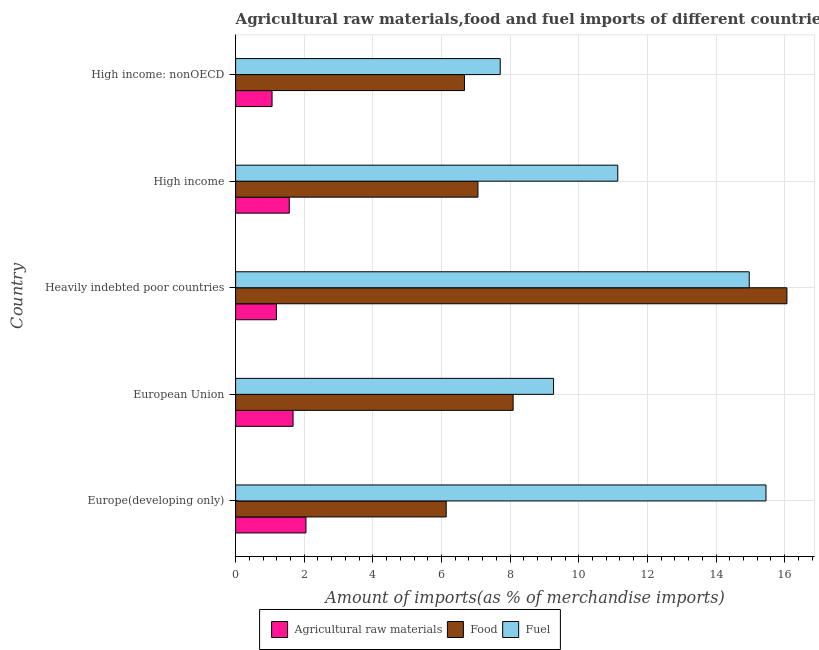How many groups of bars are there?
Offer a terse response. 5. Are the number of bars per tick equal to the number of legend labels?
Provide a succinct answer. Yes. How many bars are there on the 1st tick from the top?
Provide a succinct answer. 3. How many bars are there on the 1st tick from the bottom?
Your answer should be compact. 3. What is the label of the 1st group of bars from the top?
Give a very brief answer. High income: nonOECD. In how many cases, is the number of bars for a given country not equal to the number of legend labels?
Your answer should be compact. 0. What is the percentage of food imports in Europe(developing only)?
Provide a succinct answer. 6.14. Across all countries, what is the maximum percentage of raw materials imports?
Provide a short and direct response. 2.05. Across all countries, what is the minimum percentage of fuel imports?
Offer a very short reply. 7.71. In which country was the percentage of raw materials imports maximum?
Keep it short and to the point. Europe(developing only). In which country was the percentage of fuel imports minimum?
Ensure brevity in your answer.  High income: nonOECD. What is the total percentage of food imports in the graph?
Your answer should be compact. 44.02. What is the difference between the percentage of fuel imports in European Union and that in Heavily indebted poor countries?
Offer a terse response. -5.7. What is the difference between the percentage of food imports in Europe(developing only) and the percentage of fuel imports in Heavily indebted poor countries?
Give a very brief answer. -8.83. What is the average percentage of raw materials imports per country?
Ensure brevity in your answer.  1.51. What is the difference between the percentage of fuel imports and percentage of food imports in Europe(developing only)?
Give a very brief answer. 9.32. In how many countries, is the percentage of food imports greater than 6.8 %?
Your answer should be compact. 3. What is the ratio of the percentage of raw materials imports in Europe(developing only) to that in High income: nonOECD?
Make the answer very short. 1.93. Is the percentage of fuel imports in European Union less than that in High income: nonOECD?
Your answer should be compact. No. Is the difference between the percentage of fuel imports in High income and High income: nonOECD greater than the difference between the percentage of food imports in High income and High income: nonOECD?
Your response must be concise. Yes. What is the difference between the highest and the second highest percentage of fuel imports?
Your answer should be very brief. 0.49. What is the difference between the highest and the lowest percentage of fuel imports?
Offer a terse response. 7.74. In how many countries, is the percentage of fuel imports greater than the average percentage of fuel imports taken over all countries?
Ensure brevity in your answer.  2. Is the sum of the percentage of food imports in European Union and High income greater than the maximum percentage of fuel imports across all countries?
Keep it short and to the point. No. What does the 2nd bar from the top in Heavily indebted poor countries represents?
Provide a short and direct response. Food. What does the 1st bar from the bottom in High income represents?
Your answer should be compact. Agricultural raw materials. Is it the case that in every country, the sum of the percentage of raw materials imports and percentage of food imports is greater than the percentage of fuel imports?
Your response must be concise. No. What is the difference between two consecutive major ticks on the X-axis?
Offer a terse response. 2. Are the values on the major ticks of X-axis written in scientific E-notation?
Give a very brief answer. No. Does the graph contain grids?
Offer a terse response. Yes. How many legend labels are there?
Provide a succinct answer. 3. What is the title of the graph?
Offer a terse response. Agricultural raw materials,food and fuel imports of different countries in 2004. Does "Resident buildings and public services" appear as one of the legend labels in the graph?
Ensure brevity in your answer.  No. What is the label or title of the X-axis?
Make the answer very short. Amount of imports(as % of merchandise imports). What is the Amount of imports(as % of merchandise imports) of Agricultural raw materials in Europe(developing only)?
Keep it short and to the point. 2.05. What is the Amount of imports(as % of merchandise imports) in Food in Europe(developing only)?
Your answer should be compact. 6.14. What is the Amount of imports(as % of merchandise imports) of Fuel in Europe(developing only)?
Offer a terse response. 15.45. What is the Amount of imports(as % of merchandise imports) in Agricultural raw materials in European Union?
Keep it short and to the point. 1.67. What is the Amount of imports(as % of merchandise imports) in Food in European Union?
Make the answer very short. 8.09. What is the Amount of imports(as % of merchandise imports) in Fuel in European Union?
Make the answer very short. 9.26. What is the Amount of imports(as % of merchandise imports) of Agricultural raw materials in Heavily indebted poor countries?
Provide a short and direct response. 1.19. What is the Amount of imports(as % of merchandise imports) of Food in Heavily indebted poor countries?
Give a very brief answer. 16.06. What is the Amount of imports(as % of merchandise imports) in Fuel in Heavily indebted poor countries?
Ensure brevity in your answer.  14.97. What is the Amount of imports(as % of merchandise imports) of Agricultural raw materials in High income?
Provide a short and direct response. 1.56. What is the Amount of imports(as % of merchandise imports) in Food in High income?
Provide a succinct answer. 7.06. What is the Amount of imports(as % of merchandise imports) in Fuel in High income?
Your answer should be compact. 11.14. What is the Amount of imports(as % of merchandise imports) in Agricultural raw materials in High income: nonOECD?
Provide a short and direct response. 1.06. What is the Amount of imports(as % of merchandise imports) in Food in High income: nonOECD?
Keep it short and to the point. 6.67. What is the Amount of imports(as % of merchandise imports) in Fuel in High income: nonOECD?
Ensure brevity in your answer.  7.71. Across all countries, what is the maximum Amount of imports(as % of merchandise imports) of Agricultural raw materials?
Offer a very short reply. 2.05. Across all countries, what is the maximum Amount of imports(as % of merchandise imports) in Food?
Make the answer very short. 16.06. Across all countries, what is the maximum Amount of imports(as % of merchandise imports) in Fuel?
Offer a very short reply. 15.45. Across all countries, what is the minimum Amount of imports(as % of merchandise imports) of Agricultural raw materials?
Provide a succinct answer. 1.06. Across all countries, what is the minimum Amount of imports(as % of merchandise imports) in Food?
Provide a short and direct response. 6.14. Across all countries, what is the minimum Amount of imports(as % of merchandise imports) of Fuel?
Keep it short and to the point. 7.71. What is the total Amount of imports(as % of merchandise imports) in Agricultural raw materials in the graph?
Give a very brief answer. 7.54. What is the total Amount of imports(as % of merchandise imports) in Food in the graph?
Offer a very short reply. 44.02. What is the total Amount of imports(as % of merchandise imports) in Fuel in the graph?
Provide a short and direct response. 58.53. What is the difference between the Amount of imports(as % of merchandise imports) in Agricultural raw materials in Europe(developing only) and that in European Union?
Provide a short and direct response. 0.38. What is the difference between the Amount of imports(as % of merchandise imports) of Food in Europe(developing only) and that in European Union?
Make the answer very short. -1.95. What is the difference between the Amount of imports(as % of merchandise imports) in Fuel in Europe(developing only) and that in European Union?
Ensure brevity in your answer.  6.19. What is the difference between the Amount of imports(as % of merchandise imports) in Agricultural raw materials in Europe(developing only) and that in Heavily indebted poor countries?
Your answer should be very brief. 0.86. What is the difference between the Amount of imports(as % of merchandise imports) in Food in Europe(developing only) and that in Heavily indebted poor countries?
Provide a succinct answer. -9.93. What is the difference between the Amount of imports(as % of merchandise imports) of Fuel in Europe(developing only) and that in Heavily indebted poor countries?
Offer a very short reply. 0.49. What is the difference between the Amount of imports(as % of merchandise imports) in Agricultural raw materials in Europe(developing only) and that in High income?
Provide a short and direct response. 0.49. What is the difference between the Amount of imports(as % of merchandise imports) of Food in Europe(developing only) and that in High income?
Give a very brief answer. -0.92. What is the difference between the Amount of imports(as % of merchandise imports) in Fuel in Europe(developing only) and that in High income?
Provide a short and direct response. 4.32. What is the difference between the Amount of imports(as % of merchandise imports) in Agricultural raw materials in Europe(developing only) and that in High income: nonOECD?
Offer a very short reply. 0.99. What is the difference between the Amount of imports(as % of merchandise imports) in Food in Europe(developing only) and that in High income: nonOECD?
Make the answer very short. -0.53. What is the difference between the Amount of imports(as % of merchandise imports) in Fuel in Europe(developing only) and that in High income: nonOECD?
Your answer should be very brief. 7.74. What is the difference between the Amount of imports(as % of merchandise imports) in Agricultural raw materials in European Union and that in Heavily indebted poor countries?
Offer a terse response. 0.49. What is the difference between the Amount of imports(as % of merchandise imports) of Food in European Union and that in Heavily indebted poor countries?
Ensure brevity in your answer.  -7.98. What is the difference between the Amount of imports(as % of merchandise imports) of Fuel in European Union and that in Heavily indebted poor countries?
Your response must be concise. -5.7. What is the difference between the Amount of imports(as % of merchandise imports) of Agricultural raw materials in European Union and that in High income?
Your answer should be very brief. 0.11. What is the difference between the Amount of imports(as % of merchandise imports) of Food in European Union and that in High income?
Your response must be concise. 1.03. What is the difference between the Amount of imports(as % of merchandise imports) of Fuel in European Union and that in High income?
Offer a very short reply. -1.87. What is the difference between the Amount of imports(as % of merchandise imports) in Agricultural raw materials in European Union and that in High income: nonOECD?
Ensure brevity in your answer.  0.61. What is the difference between the Amount of imports(as % of merchandise imports) of Food in European Union and that in High income: nonOECD?
Ensure brevity in your answer.  1.42. What is the difference between the Amount of imports(as % of merchandise imports) in Fuel in European Union and that in High income: nonOECD?
Give a very brief answer. 1.55. What is the difference between the Amount of imports(as % of merchandise imports) of Agricultural raw materials in Heavily indebted poor countries and that in High income?
Your answer should be very brief. -0.38. What is the difference between the Amount of imports(as % of merchandise imports) in Food in Heavily indebted poor countries and that in High income?
Offer a terse response. 9. What is the difference between the Amount of imports(as % of merchandise imports) in Fuel in Heavily indebted poor countries and that in High income?
Provide a succinct answer. 3.83. What is the difference between the Amount of imports(as % of merchandise imports) of Agricultural raw materials in Heavily indebted poor countries and that in High income: nonOECD?
Ensure brevity in your answer.  0.13. What is the difference between the Amount of imports(as % of merchandise imports) of Food in Heavily indebted poor countries and that in High income: nonOECD?
Make the answer very short. 9.4. What is the difference between the Amount of imports(as % of merchandise imports) in Fuel in Heavily indebted poor countries and that in High income: nonOECD?
Your answer should be very brief. 7.26. What is the difference between the Amount of imports(as % of merchandise imports) of Agricultural raw materials in High income and that in High income: nonOECD?
Offer a terse response. 0.5. What is the difference between the Amount of imports(as % of merchandise imports) of Food in High income and that in High income: nonOECD?
Provide a succinct answer. 0.39. What is the difference between the Amount of imports(as % of merchandise imports) in Fuel in High income and that in High income: nonOECD?
Your answer should be compact. 3.43. What is the difference between the Amount of imports(as % of merchandise imports) in Agricultural raw materials in Europe(developing only) and the Amount of imports(as % of merchandise imports) in Food in European Union?
Ensure brevity in your answer.  -6.04. What is the difference between the Amount of imports(as % of merchandise imports) in Agricultural raw materials in Europe(developing only) and the Amount of imports(as % of merchandise imports) in Fuel in European Union?
Make the answer very short. -7.22. What is the difference between the Amount of imports(as % of merchandise imports) of Food in Europe(developing only) and the Amount of imports(as % of merchandise imports) of Fuel in European Union?
Give a very brief answer. -3.13. What is the difference between the Amount of imports(as % of merchandise imports) of Agricultural raw materials in Europe(developing only) and the Amount of imports(as % of merchandise imports) of Food in Heavily indebted poor countries?
Provide a short and direct response. -14.02. What is the difference between the Amount of imports(as % of merchandise imports) in Agricultural raw materials in Europe(developing only) and the Amount of imports(as % of merchandise imports) in Fuel in Heavily indebted poor countries?
Your response must be concise. -12.92. What is the difference between the Amount of imports(as % of merchandise imports) in Food in Europe(developing only) and the Amount of imports(as % of merchandise imports) in Fuel in Heavily indebted poor countries?
Keep it short and to the point. -8.83. What is the difference between the Amount of imports(as % of merchandise imports) in Agricultural raw materials in Europe(developing only) and the Amount of imports(as % of merchandise imports) in Food in High income?
Keep it short and to the point. -5.01. What is the difference between the Amount of imports(as % of merchandise imports) of Agricultural raw materials in Europe(developing only) and the Amount of imports(as % of merchandise imports) of Fuel in High income?
Provide a succinct answer. -9.09. What is the difference between the Amount of imports(as % of merchandise imports) of Food in Europe(developing only) and the Amount of imports(as % of merchandise imports) of Fuel in High income?
Offer a very short reply. -5. What is the difference between the Amount of imports(as % of merchandise imports) in Agricultural raw materials in Europe(developing only) and the Amount of imports(as % of merchandise imports) in Food in High income: nonOECD?
Make the answer very short. -4.62. What is the difference between the Amount of imports(as % of merchandise imports) in Agricultural raw materials in Europe(developing only) and the Amount of imports(as % of merchandise imports) in Fuel in High income: nonOECD?
Keep it short and to the point. -5.66. What is the difference between the Amount of imports(as % of merchandise imports) of Food in Europe(developing only) and the Amount of imports(as % of merchandise imports) of Fuel in High income: nonOECD?
Your answer should be compact. -1.57. What is the difference between the Amount of imports(as % of merchandise imports) in Agricultural raw materials in European Union and the Amount of imports(as % of merchandise imports) in Food in Heavily indebted poor countries?
Ensure brevity in your answer.  -14.39. What is the difference between the Amount of imports(as % of merchandise imports) of Agricultural raw materials in European Union and the Amount of imports(as % of merchandise imports) of Fuel in Heavily indebted poor countries?
Give a very brief answer. -13.29. What is the difference between the Amount of imports(as % of merchandise imports) of Food in European Union and the Amount of imports(as % of merchandise imports) of Fuel in Heavily indebted poor countries?
Keep it short and to the point. -6.88. What is the difference between the Amount of imports(as % of merchandise imports) of Agricultural raw materials in European Union and the Amount of imports(as % of merchandise imports) of Food in High income?
Your answer should be very brief. -5.39. What is the difference between the Amount of imports(as % of merchandise imports) in Agricultural raw materials in European Union and the Amount of imports(as % of merchandise imports) in Fuel in High income?
Keep it short and to the point. -9.46. What is the difference between the Amount of imports(as % of merchandise imports) of Food in European Union and the Amount of imports(as % of merchandise imports) of Fuel in High income?
Offer a very short reply. -3.05. What is the difference between the Amount of imports(as % of merchandise imports) of Agricultural raw materials in European Union and the Amount of imports(as % of merchandise imports) of Food in High income: nonOECD?
Your response must be concise. -4.99. What is the difference between the Amount of imports(as % of merchandise imports) in Agricultural raw materials in European Union and the Amount of imports(as % of merchandise imports) in Fuel in High income: nonOECD?
Offer a very short reply. -6.04. What is the difference between the Amount of imports(as % of merchandise imports) in Food in European Union and the Amount of imports(as % of merchandise imports) in Fuel in High income: nonOECD?
Keep it short and to the point. 0.38. What is the difference between the Amount of imports(as % of merchandise imports) of Agricultural raw materials in Heavily indebted poor countries and the Amount of imports(as % of merchandise imports) of Food in High income?
Your answer should be very brief. -5.87. What is the difference between the Amount of imports(as % of merchandise imports) of Agricultural raw materials in Heavily indebted poor countries and the Amount of imports(as % of merchandise imports) of Fuel in High income?
Your response must be concise. -9.95. What is the difference between the Amount of imports(as % of merchandise imports) in Food in Heavily indebted poor countries and the Amount of imports(as % of merchandise imports) in Fuel in High income?
Ensure brevity in your answer.  4.93. What is the difference between the Amount of imports(as % of merchandise imports) in Agricultural raw materials in Heavily indebted poor countries and the Amount of imports(as % of merchandise imports) in Food in High income: nonOECD?
Your answer should be compact. -5.48. What is the difference between the Amount of imports(as % of merchandise imports) of Agricultural raw materials in Heavily indebted poor countries and the Amount of imports(as % of merchandise imports) of Fuel in High income: nonOECD?
Your answer should be very brief. -6.52. What is the difference between the Amount of imports(as % of merchandise imports) of Food in Heavily indebted poor countries and the Amount of imports(as % of merchandise imports) of Fuel in High income: nonOECD?
Provide a succinct answer. 8.35. What is the difference between the Amount of imports(as % of merchandise imports) in Agricultural raw materials in High income and the Amount of imports(as % of merchandise imports) in Food in High income: nonOECD?
Your answer should be compact. -5.1. What is the difference between the Amount of imports(as % of merchandise imports) in Agricultural raw materials in High income and the Amount of imports(as % of merchandise imports) in Fuel in High income: nonOECD?
Keep it short and to the point. -6.15. What is the difference between the Amount of imports(as % of merchandise imports) in Food in High income and the Amount of imports(as % of merchandise imports) in Fuel in High income: nonOECD?
Give a very brief answer. -0.65. What is the average Amount of imports(as % of merchandise imports) of Agricultural raw materials per country?
Make the answer very short. 1.51. What is the average Amount of imports(as % of merchandise imports) of Food per country?
Make the answer very short. 8.8. What is the average Amount of imports(as % of merchandise imports) of Fuel per country?
Your answer should be compact. 11.71. What is the difference between the Amount of imports(as % of merchandise imports) in Agricultural raw materials and Amount of imports(as % of merchandise imports) in Food in Europe(developing only)?
Keep it short and to the point. -4.09. What is the difference between the Amount of imports(as % of merchandise imports) in Agricultural raw materials and Amount of imports(as % of merchandise imports) in Fuel in Europe(developing only)?
Keep it short and to the point. -13.41. What is the difference between the Amount of imports(as % of merchandise imports) of Food and Amount of imports(as % of merchandise imports) of Fuel in Europe(developing only)?
Your answer should be compact. -9.32. What is the difference between the Amount of imports(as % of merchandise imports) in Agricultural raw materials and Amount of imports(as % of merchandise imports) in Food in European Union?
Make the answer very short. -6.41. What is the difference between the Amount of imports(as % of merchandise imports) of Agricultural raw materials and Amount of imports(as % of merchandise imports) of Fuel in European Union?
Your answer should be compact. -7.59. What is the difference between the Amount of imports(as % of merchandise imports) in Food and Amount of imports(as % of merchandise imports) in Fuel in European Union?
Your answer should be very brief. -1.18. What is the difference between the Amount of imports(as % of merchandise imports) of Agricultural raw materials and Amount of imports(as % of merchandise imports) of Food in Heavily indebted poor countries?
Keep it short and to the point. -14.88. What is the difference between the Amount of imports(as % of merchandise imports) of Agricultural raw materials and Amount of imports(as % of merchandise imports) of Fuel in Heavily indebted poor countries?
Your response must be concise. -13.78. What is the difference between the Amount of imports(as % of merchandise imports) in Food and Amount of imports(as % of merchandise imports) in Fuel in Heavily indebted poor countries?
Your response must be concise. 1.1. What is the difference between the Amount of imports(as % of merchandise imports) of Agricultural raw materials and Amount of imports(as % of merchandise imports) of Food in High income?
Your answer should be compact. -5.5. What is the difference between the Amount of imports(as % of merchandise imports) in Agricultural raw materials and Amount of imports(as % of merchandise imports) in Fuel in High income?
Offer a terse response. -9.57. What is the difference between the Amount of imports(as % of merchandise imports) in Food and Amount of imports(as % of merchandise imports) in Fuel in High income?
Offer a terse response. -4.07. What is the difference between the Amount of imports(as % of merchandise imports) of Agricultural raw materials and Amount of imports(as % of merchandise imports) of Food in High income: nonOECD?
Keep it short and to the point. -5.61. What is the difference between the Amount of imports(as % of merchandise imports) of Agricultural raw materials and Amount of imports(as % of merchandise imports) of Fuel in High income: nonOECD?
Your answer should be compact. -6.65. What is the difference between the Amount of imports(as % of merchandise imports) in Food and Amount of imports(as % of merchandise imports) in Fuel in High income: nonOECD?
Give a very brief answer. -1.04. What is the ratio of the Amount of imports(as % of merchandise imports) of Agricultural raw materials in Europe(developing only) to that in European Union?
Provide a short and direct response. 1.22. What is the ratio of the Amount of imports(as % of merchandise imports) of Food in Europe(developing only) to that in European Union?
Give a very brief answer. 0.76. What is the ratio of the Amount of imports(as % of merchandise imports) in Fuel in Europe(developing only) to that in European Union?
Provide a short and direct response. 1.67. What is the ratio of the Amount of imports(as % of merchandise imports) of Agricultural raw materials in Europe(developing only) to that in Heavily indebted poor countries?
Offer a terse response. 1.73. What is the ratio of the Amount of imports(as % of merchandise imports) in Food in Europe(developing only) to that in Heavily indebted poor countries?
Your answer should be very brief. 0.38. What is the ratio of the Amount of imports(as % of merchandise imports) of Fuel in Europe(developing only) to that in Heavily indebted poor countries?
Your answer should be very brief. 1.03. What is the ratio of the Amount of imports(as % of merchandise imports) of Agricultural raw materials in Europe(developing only) to that in High income?
Your response must be concise. 1.31. What is the ratio of the Amount of imports(as % of merchandise imports) in Food in Europe(developing only) to that in High income?
Keep it short and to the point. 0.87. What is the ratio of the Amount of imports(as % of merchandise imports) of Fuel in Europe(developing only) to that in High income?
Make the answer very short. 1.39. What is the ratio of the Amount of imports(as % of merchandise imports) of Agricultural raw materials in Europe(developing only) to that in High income: nonOECD?
Ensure brevity in your answer.  1.93. What is the ratio of the Amount of imports(as % of merchandise imports) in Food in Europe(developing only) to that in High income: nonOECD?
Offer a terse response. 0.92. What is the ratio of the Amount of imports(as % of merchandise imports) in Fuel in Europe(developing only) to that in High income: nonOECD?
Make the answer very short. 2. What is the ratio of the Amount of imports(as % of merchandise imports) of Agricultural raw materials in European Union to that in Heavily indebted poor countries?
Your answer should be compact. 1.41. What is the ratio of the Amount of imports(as % of merchandise imports) of Food in European Union to that in Heavily indebted poor countries?
Make the answer very short. 0.5. What is the ratio of the Amount of imports(as % of merchandise imports) in Fuel in European Union to that in Heavily indebted poor countries?
Ensure brevity in your answer.  0.62. What is the ratio of the Amount of imports(as % of merchandise imports) in Agricultural raw materials in European Union to that in High income?
Ensure brevity in your answer.  1.07. What is the ratio of the Amount of imports(as % of merchandise imports) of Food in European Union to that in High income?
Provide a short and direct response. 1.15. What is the ratio of the Amount of imports(as % of merchandise imports) in Fuel in European Union to that in High income?
Provide a short and direct response. 0.83. What is the ratio of the Amount of imports(as % of merchandise imports) of Agricultural raw materials in European Union to that in High income: nonOECD?
Give a very brief answer. 1.58. What is the ratio of the Amount of imports(as % of merchandise imports) of Food in European Union to that in High income: nonOECD?
Your response must be concise. 1.21. What is the ratio of the Amount of imports(as % of merchandise imports) in Fuel in European Union to that in High income: nonOECD?
Your answer should be very brief. 1.2. What is the ratio of the Amount of imports(as % of merchandise imports) of Agricultural raw materials in Heavily indebted poor countries to that in High income?
Ensure brevity in your answer.  0.76. What is the ratio of the Amount of imports(as % of merchandise imports) in Food in Heavily indebted poor countries to that in High income?
Your response must be concise. 2.28. What is the ratio of the Amount of imports(as % of merchandise imports) in Fuel in Heavily indebted poor countries to that in High income?
Give a very brief answer. 1.34. What is the ratio of the Amount of imports(as % of merchandise imports) in Agricultural raw materials in Heavily indebted poor countries to that in High income: nonOECD?
Offer a very short reply. 1.12. What is the ratio of the Amount of imports(as % of merchandise imports) in Food in Heavily indebted poor countries to that in High income: nonOECD?
Give a very brief answer. 2.41. What is the ratio of the Amount of imports(as % of merchandise imports) in Fuel in Heavily indebted poor countries to that in High income: nonOECD?
Your answer should be compact. 1.94. What is the ratio of the Amount of imports(as % of merchandise imports) in Agricultural raw materials in High income to that in High income: nonOECD?
Your answer should be compact. 1.47. What is the ratio of the Amount of imports(as % of merchandise imports) of Food in High income to that in High income: nonOECD?
Offer a terse response. 1.06. What is the ratio of the Amount of imports(as % of merchandise imports) of Fuel in High income to that in High income: nonOECD?
Provide a short and direct response. 1.44. What is the difference between the highest and the second highest Amount of imports(as % of merchandise imports) of Agricultural raw materials?
Your answer should be very brief. 0.38. What is the difference between the highest and the second highest Amount of imports(as % of merchandise imports) of Food?
Ensure brevity in your answer.  7.98. What is the difference between the highest and the second highest Amount of imports(as % of merchandise imports) of Fuel?
Your answer should be very brief. 0.49. What is the difference between the highest and the lowest Amount of imports(as % of merchandise imports) of Agricultural raw materials?
Offer a terse response. 0.99. What is the difference between the highest and the lowest Amount of imports(as % of merchandise imports) of Food?
Offer a terse response. 9.93. What is the difference between the highest and the lowest Amount of imports(as % of merchandise imports) in Fuel?
Provide a short and direct response. 7.74. 